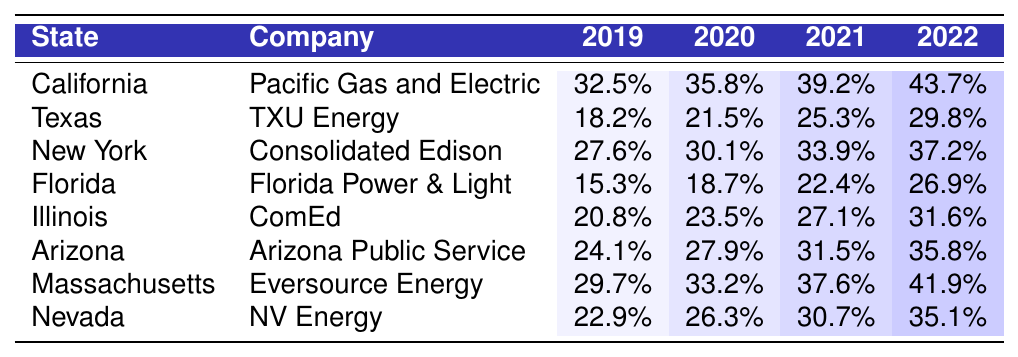What was the adoption rate for California in 2021? In the table, locate the row for California. Then, look under the 2021 Adoption Rate column, which shows 39.2%.
Answer: 39.2% Which state had the highest adoption rate in 2022? Examine the values in the 2022 Adoption Rate column. California has the highest value at 43.7%, compared to others.
Answer: California What is the difference in adoption rates for Texas from 2019 to 2022? Find the adoption rates for Texas in 2019 (18.2%) and 2022 (29.8%). Calculate the difference: 29.8% - 18.2% = 11.6%.
Answer: 11.6% What is the average adoption rate for Arizona over the four years? Add the values for Arizona across all years: 24.1% + 27.9% + 31.5% + 35.8% = 119.3%. Then divide by the number of years (4): 119.3% / 4 = 29.825%.
Answer: 29.83% Did any state have an adoption rate lower than 20% in 2020? Check the 2020 Adoption Rate column; Texas (21.5%) is the closest, but Florida (18.7%) is below 20%. Therefore, yes, Florida did.
Answer: Yes Which company had the lowest adoption rate in 2019? Review the 2019 Adoption Rate column for all states. Florida Power & Light has 15.3%, the lowest compared to other companies.
Answer: Florida Power & Light What is the total increase in adoption rate for Massachusetts from 2019 to 2022? Start with the rates: 2019 (29.7%) and 2022 (41.9%). Calculate the total increase: 41.9% - 29.7% = 12.2%.
Answer: 12.2% Across all states, which year showed the largest average adoption rate? First, calculate the average for each year: 2019 (24.8%), 2020 (28.9%), 2021 (32.4%), 2022 (36.4%). The highest is 2022.
Answer: 2022 Which company made the most significant progress in adoption rates from 2019 to 2022? Calculate the increase for each company: Pacific Gas & Electric (11.2%), TXU Energy (11.6%), Consolidated Edison (9.6%), etc. TXU Energy shows the highest progress of 11.6%.
Answer: TXU Energy 